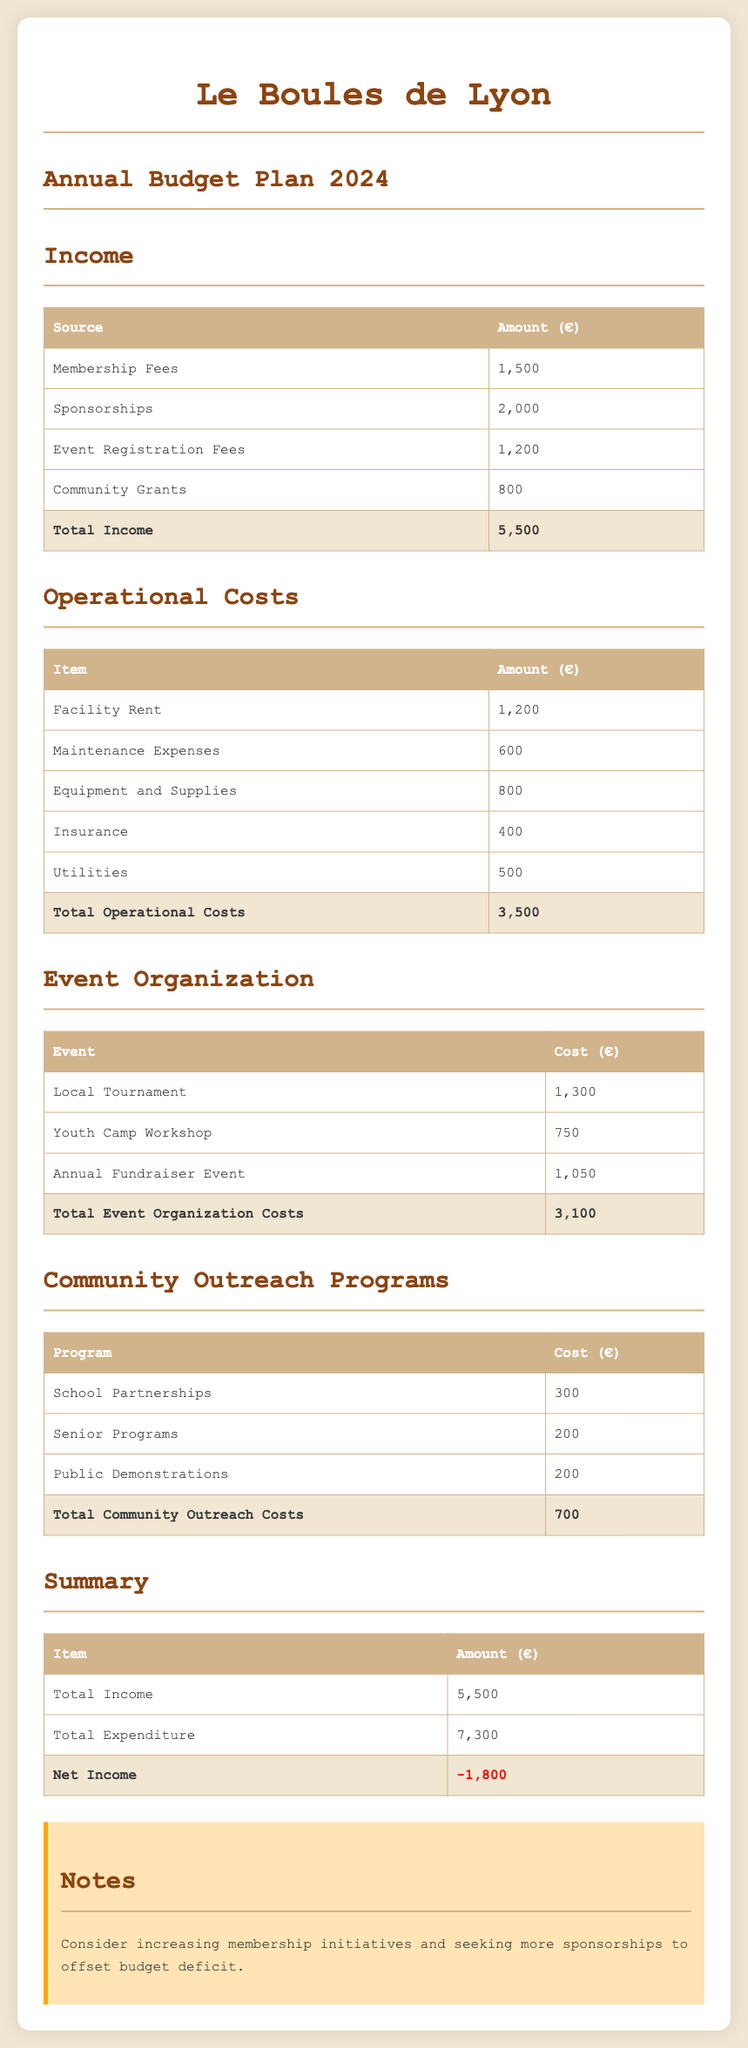What is the total income? The total income is the sum of all income sources listed in the document: 1500 + 2000 + 1200 + 800 = 5500.
Answer: 5500 What is the amount allocated for Facility Rent? The Facility Rent is listed as one of the operational costs amounting to 1200.
Answer: 1200 How much will be spent on the Local Tournament? The Local Tournament costs are detailed in the event organization section, which shows a cost of 1300.
Answer: 1300 What is the total cost of Community Outreach Programs? The total for Community Outreach Programs is given as the sum of individual program costs: 300 + 200 + 200 = 700.
Answer: 700 What is the net income? The net income is calculated as total income minus total expenditure; here, it is 5500 - 7300 = -1800.
Answer: -1800 What is the cost of the Youth Camp Workshop? The Youth Camp Workshop's cost is mentioned under event organization, amounting to 750.
Answer: 750 How much funding is received from Sponsorships? The document states that Sponsorships contribute 2000 to total income.
Answer: 2000 What recommendation is made in the Notes section? The notes suggest increasing membership initiatives and seeking more sponsorships to improve the budget situation.
Answer: Increase membership initiatives and seek more sponsorships 